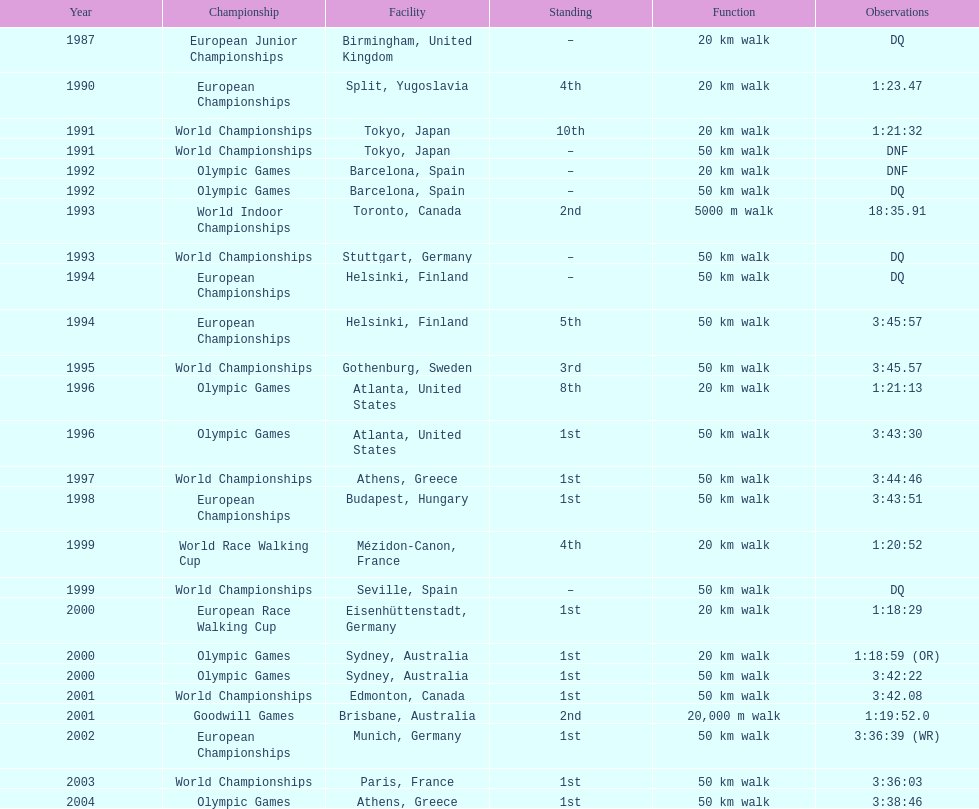How long did it take to walk 50 km in the 2004 olympic games? 3:38:46. 